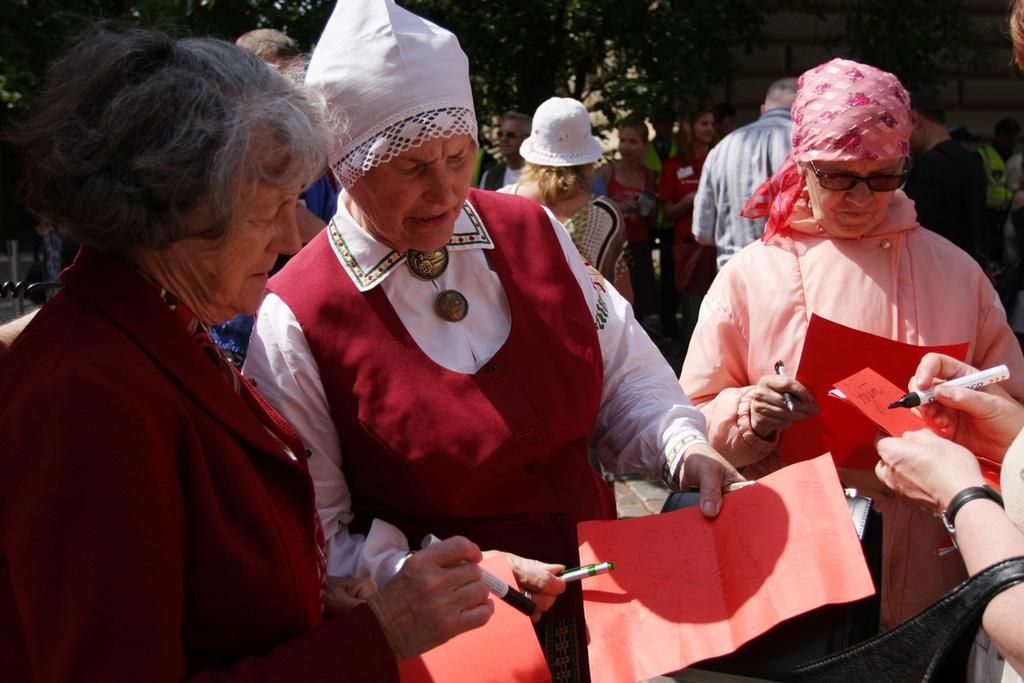What are the people in the image doing? There are people standing in the image, and some of them are holding papers and pens. Can you describe the background of the image? There are trees in the background of the image. How does the breath of the people in the image affect the trees in the background? There is no information about the people's breath in the image, and it cannot be determined how it would affect the trees in the background. 